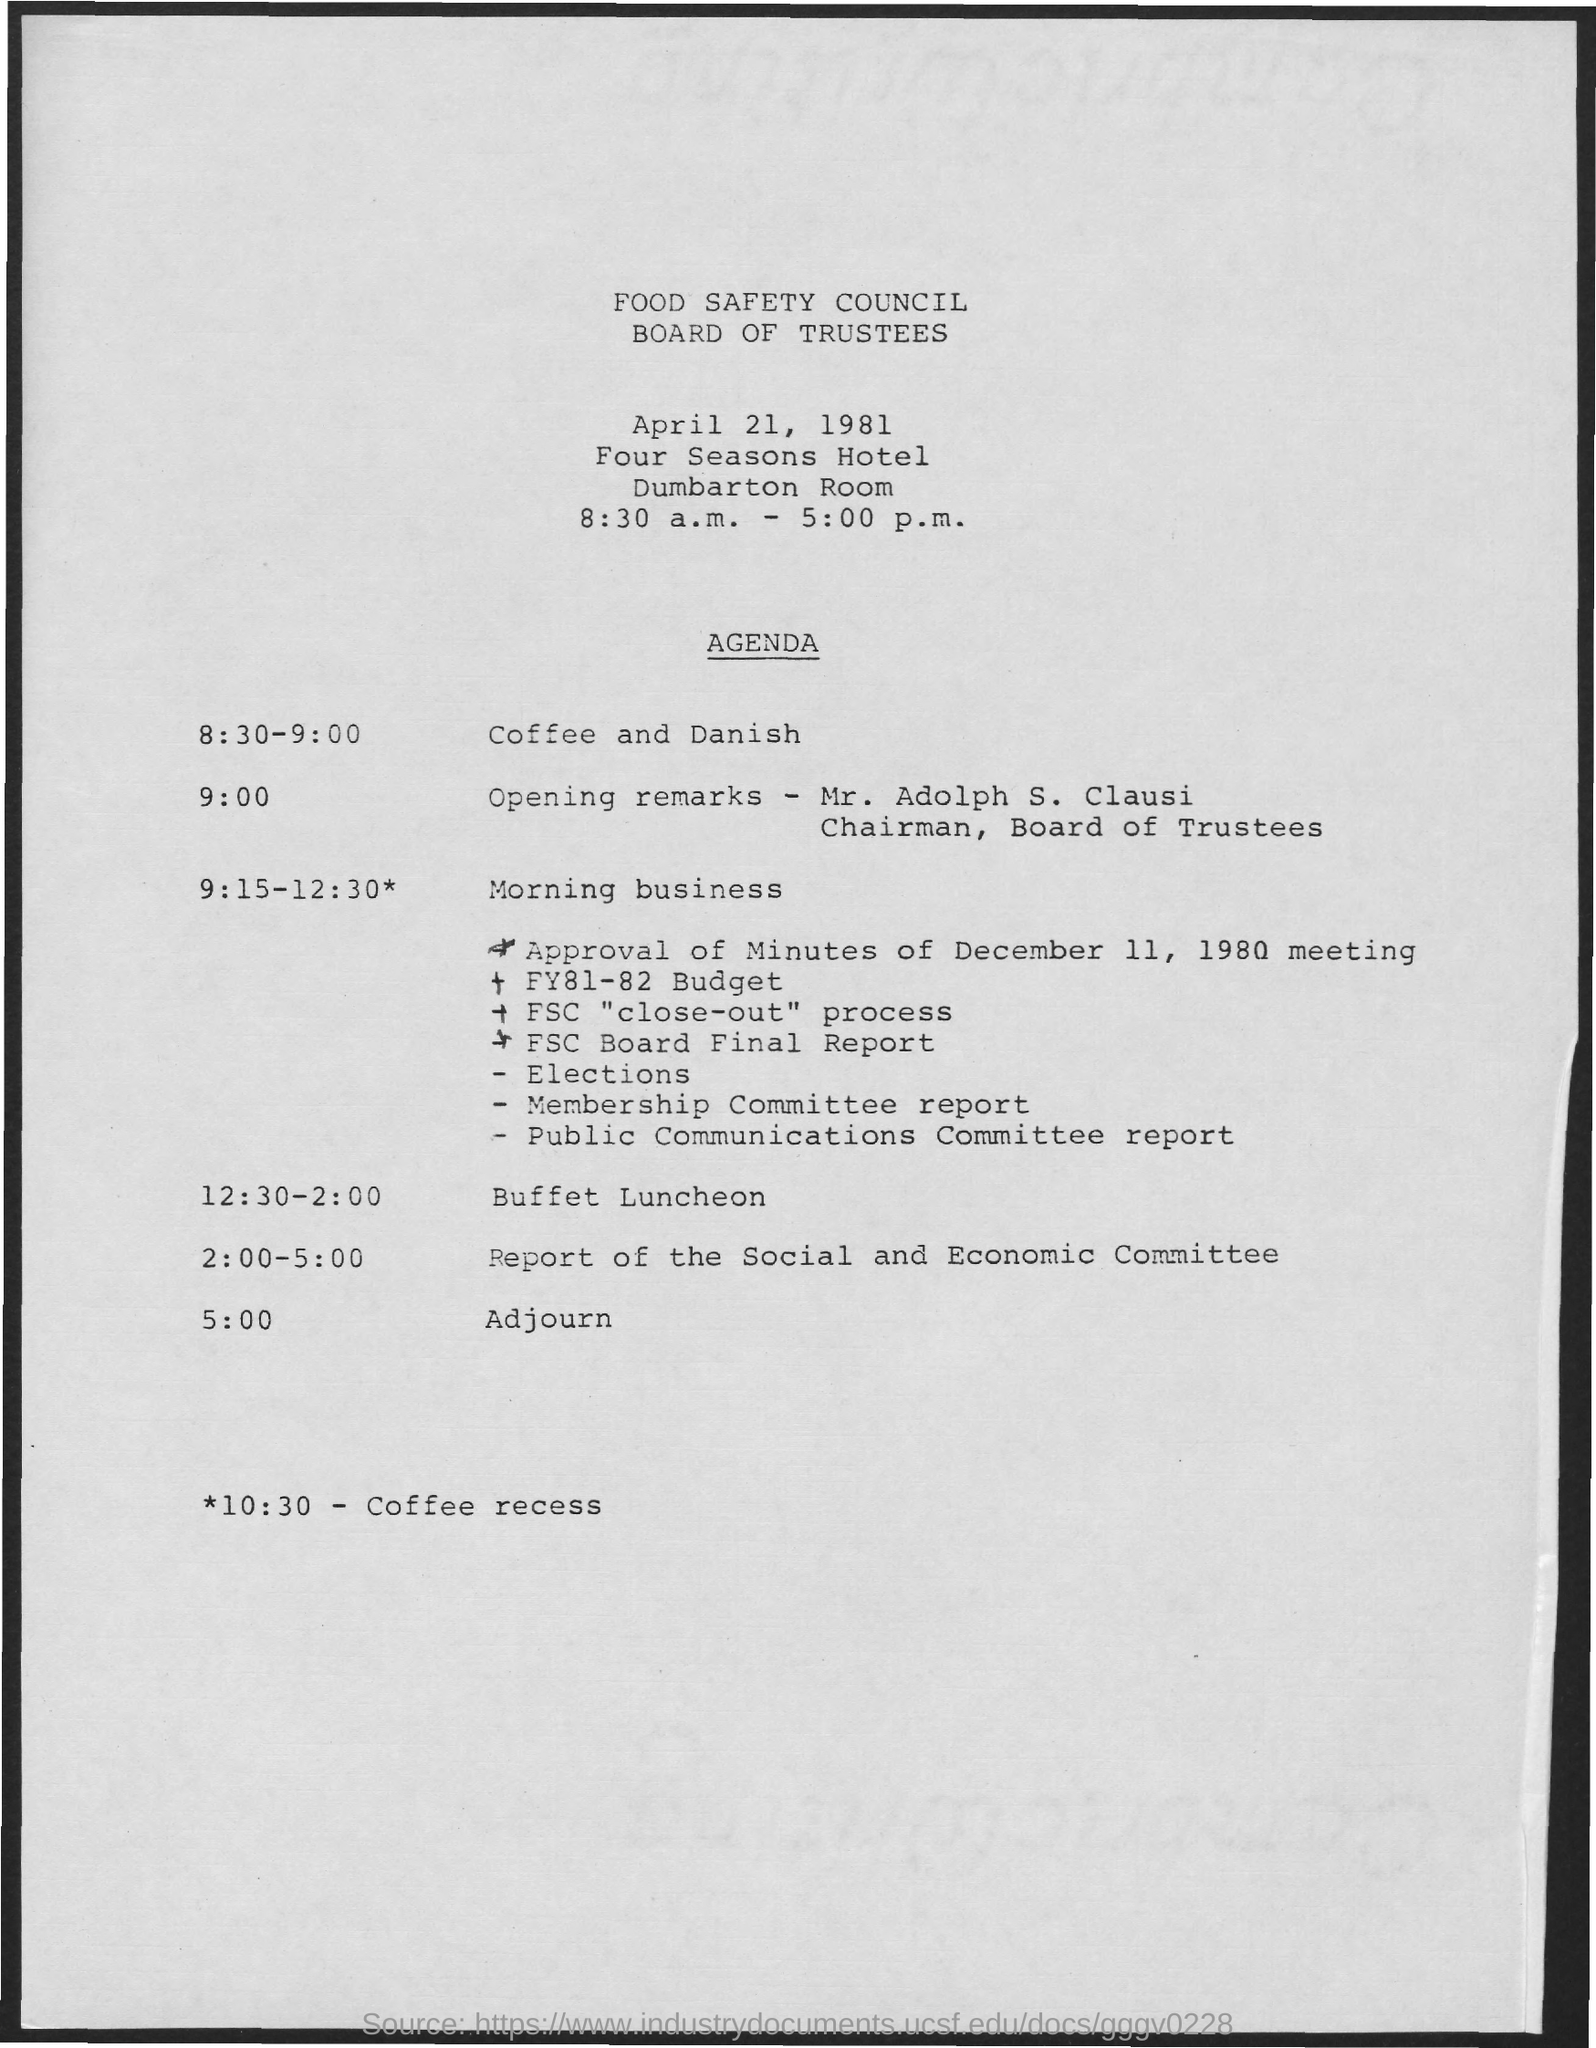Mention a couple of crucial points in this snapshot. The heading of the document is "Food Safety Council Board of Trustees. At 10:30 AM, there will be a coffee recess on the schedule. 